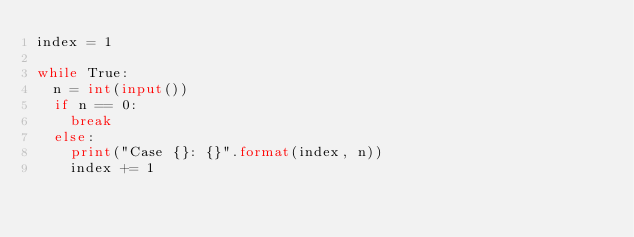Convert code to text. <code><loc_0><loc_0><loc_500><loc_500><_Python_>index = 1

while True:
  n = int(input())
  if n == 0:
    break
  else:
    print("Case {}: {}".format(index, n))
    index += 1
</code> 